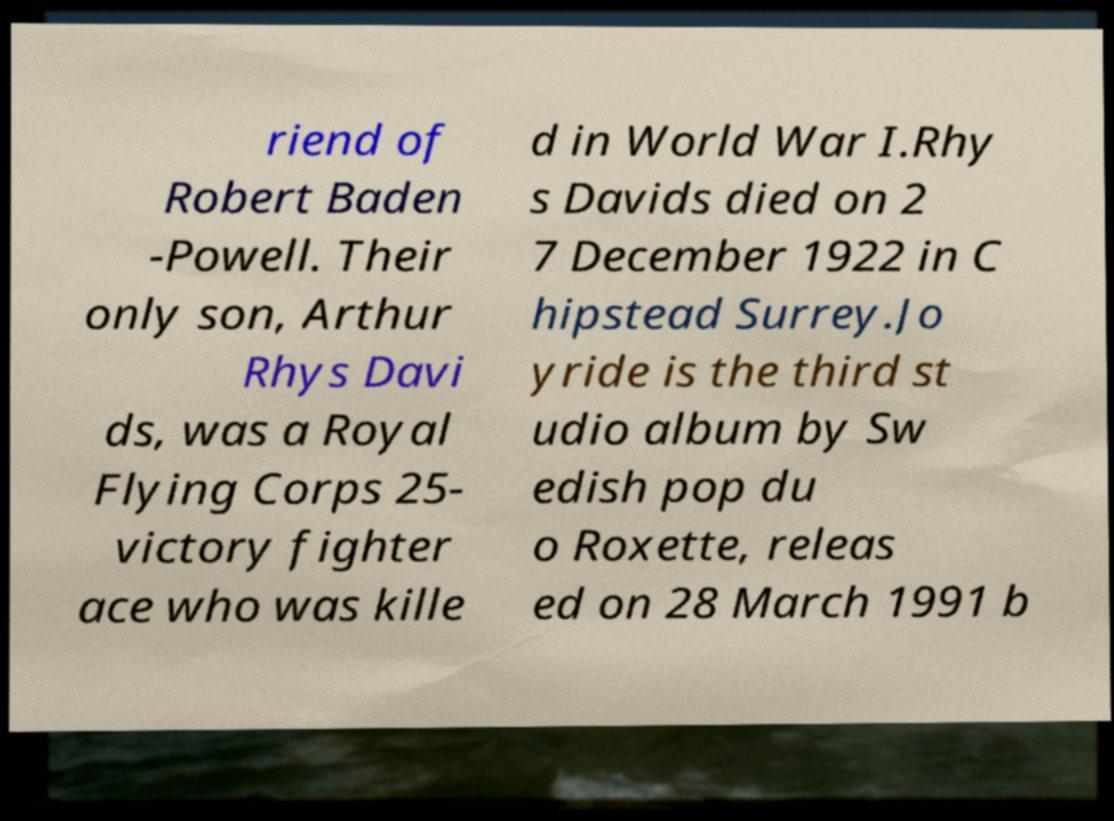For documentation purposes, I need the text within this image transcribed. Could you provide that? riend of Robert Baden -Powell. Their only son, Arthur Rhys Davi ds, was a Royal Flying Corps 25- victory fighter ace who was kille d in World War I.Rhy s Davids died on 2 7 December 1922 in C hipstead Surrey.Jo yride is the third st udio album by Sw edish pop du o Roxette, releas ed on 28 March 1991 b 